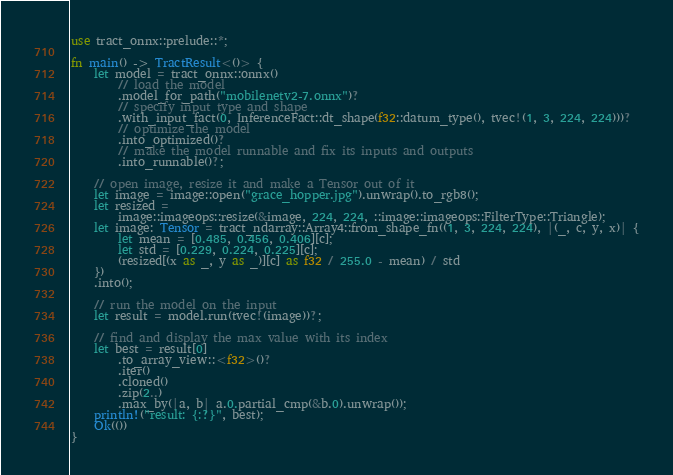Convert code to text. <code><loc_0><loc_0><loc_500><loc_500><_Rust_>use tract_onnx::prelude::*;

fn main() -> TractResult<()> {
    let model = tract_onnx::onnx()
        // load the model
        .model_for_path("mobilenetv2-7.onnx")?
        // specify input type and shape
        .with_input_fact(0, InferenceFact::dt_shape(f32::datum_type(), tvec!(1, 3, 224, 224)))?
        // optimize the model
        .into_optimized()?
        // make the model runnable and fix its inputs and outputs
        .into_runnable()?;

    // open image, resize it and make a Tensor out of it
    let image = image::open("grace_hopper.jpg").unwrap().to_rgb8();
    let resized =
        image::imageops::resize(&image, 224, 224, ::image::imageops::FilterType::Triangle);
    let image: Tensor = tract_ndarray::Array4::from_shape_fn((1, 3, 224, 224), |(_, c, y, x)| {
        let mean = [0.485, 0.456, 0.406][c];
        let std = [0.229, 0.224, 0.225][c];
        (resized[(x as _, y as _)][c] as f32 / 255.0 - mean) / std
    })
    .into();

    // run the model on the input
    let result = model.run(tvec!(image))?;

    // find and display the max value with its index
    let best = result[0]
        .to_array_view::<f32>()?
        .iter()
        .cloned()
        .zip(2..)
        .max_by(|a, b| a.0.partial_cmp(&b.0).unwrap());
    println!("result: {:?}", best);
    Ok(())
}
</code> 